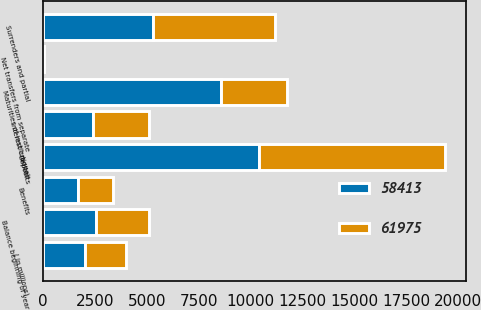<chart> <loc_0><loc_0><loc_500><loc_500><stacked_bar_chart><ecel><fcel>( in millions)<fcel>Balance beginning of year<fcel>Deposits<fcel>Interest credited<fcel>Benefits<fcel>Surrenders and partial<fcel>Maturities of institutional<fcel>Net transfers from separate<nl><fcel>58413<fcel>2008<fcel>2547<fcel>10402<fcel>2405<fcel>1710<fcel>5313<fcel>8599<fcel>19<nl><fcel>61975<fcel>2007<fcel>2547<fcel>8991<fcel>2689<fcel>1668<fcel>5872<fcel>3165<fcel>13<nl></chart> 